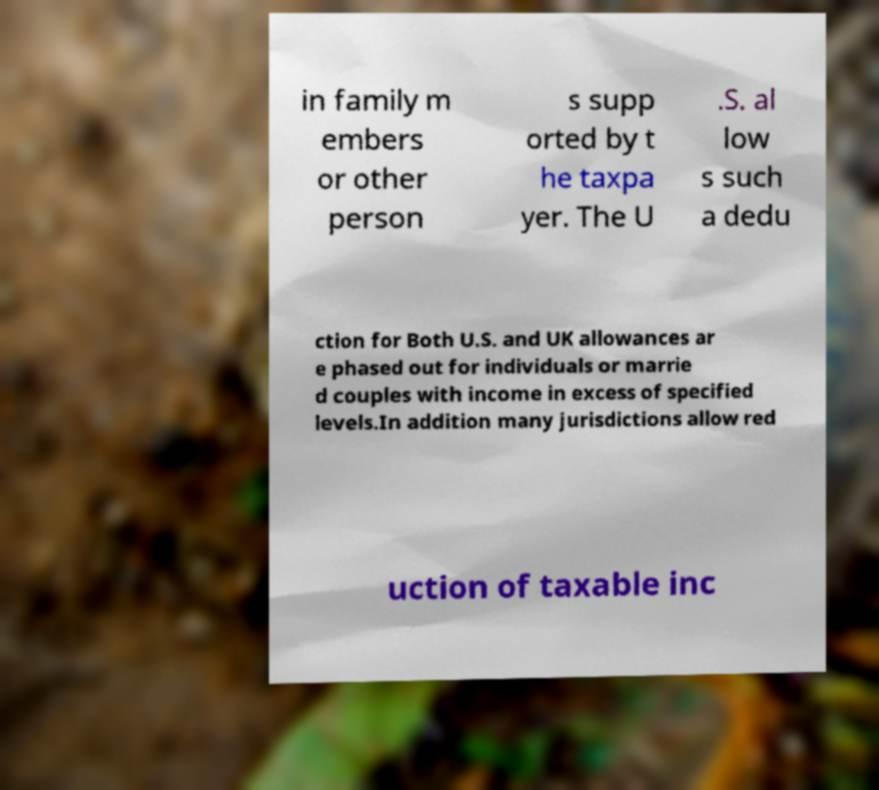Could you assist in decoding the text presented in this image and type it out clearly? in family m embers or other person s supp orted by t he taxpa yer. The U .S. al low s such a dedu ction for Both U.S. and UK allowances ar e phased out for individuals or marrie d couples with income in excess of specified levels.In addition many jurisdictions allow red uction of taxable inc 